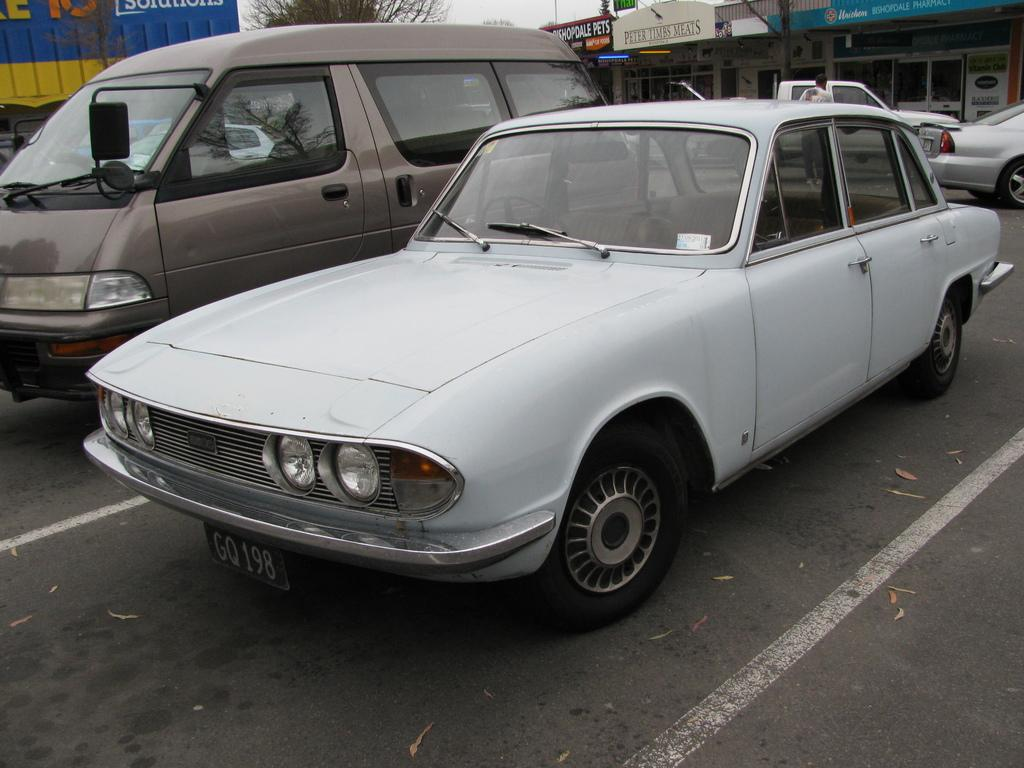What can be seen on the road in the image? There are vehicles on the road in the image. Can you describe the person in the image? There is a person in the image. What type of establishments are present in the image? There are stores in the image. What objects are present in the image that are not vehicles or stores? There are boards and a tree in the image. What is visible in the background of the image? The sky is visible in the background of the image. How many steps are visible in the image? There is no mention of steps in the image; it features vehicles, a person, stores, boards, a tree, and the sky. What design is present on the tree in the image? There is no mention of a specific design on the tree in the image; it is simply described as a tree. 